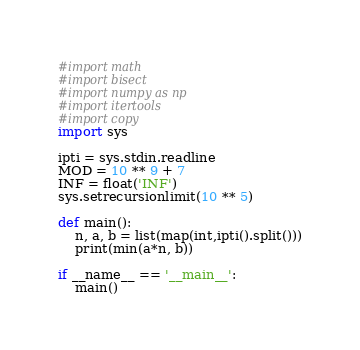Convert code to text. <code><loc_0><loc_0><loc_500><loc_500><_Python_>#import math
#import bisect
#import numpy as np
#import itertools
#import copy
import sys

ipti = sys.stdin.readline
MOD = 10 ** 9 + 7
INF = float('INF')
sys.setrecursionlimit(10 ** 5)

def main():
    n, a, b = list(map(int,ipti().split()))
    print(min(a*n, b))

if __name__ == '__main__':
    main()</code> 